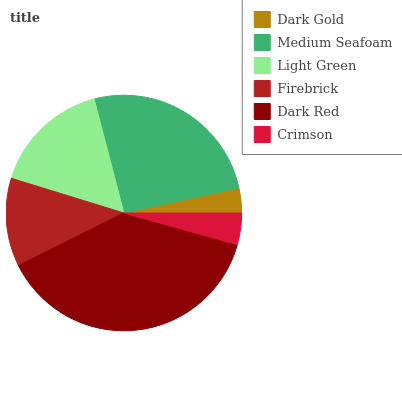Is Dark Gold the minimum?
Answer yes or no. Yes. Is Dark Red the maximum?
Answer yes or no. Yes. Is Medium Seafoam the minimum?
Answer yes or no. No. Is Medium Seafoam the maximum?
Answer yes or no. No. Is Medium Seafoam greater than Dark Gold?
Answer yes or no. Yes. Is Dark Gold less than Medium Seafoam?
Answer yes or no. Yes. Is Dark Gold greater than Medium Seafoam?
Answer yes or no. No. Is Medium Seafoam less than Dark Gold?
Answer yes or no. No. Is Light Green the high median?
Answer yes or no. Yes. Is Firebrick the low median?
Answer yes or no. Yes. Is Crimson the high median?
Answer yes or no. No. Is Crimson the low median?
Answer yes or no. No. 